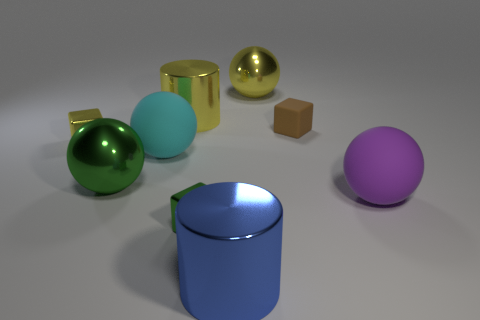Are any big cyan rubber things visible?
Keep it short and to the point. Yes. What is the size of the blue cylinder that is the same material as the green block?
Ensure brevity in your answer.  Large. Are the big blue cylinder and the tiny green block made of the same material?
Offer a terse response. Yes. How many other objects are there of the same material as the green sphere?
Give a very brief answer. 5. What number of yellow metal things are left of the large green metallic object and right of the small yellow block?
Offer a terse response. 0. The matte block has what color?
Provide a succinct answer. Brown. There is a brown thing that is the same shape as the tiny yellow object; what is it made of?
Offer a very short reply. Rubber. What shape is the green thing that is right of the rubber ball that is left of the big purple rubber thing?
Provide a short and direct response. Cube. There is a big green thing that is made of the same material as the big blue cylinder; what is its shape?
Your response must be concise. Sphere. How many other objects are the same shape as the large blue metal object?
Provide a short and direct response. 1. 